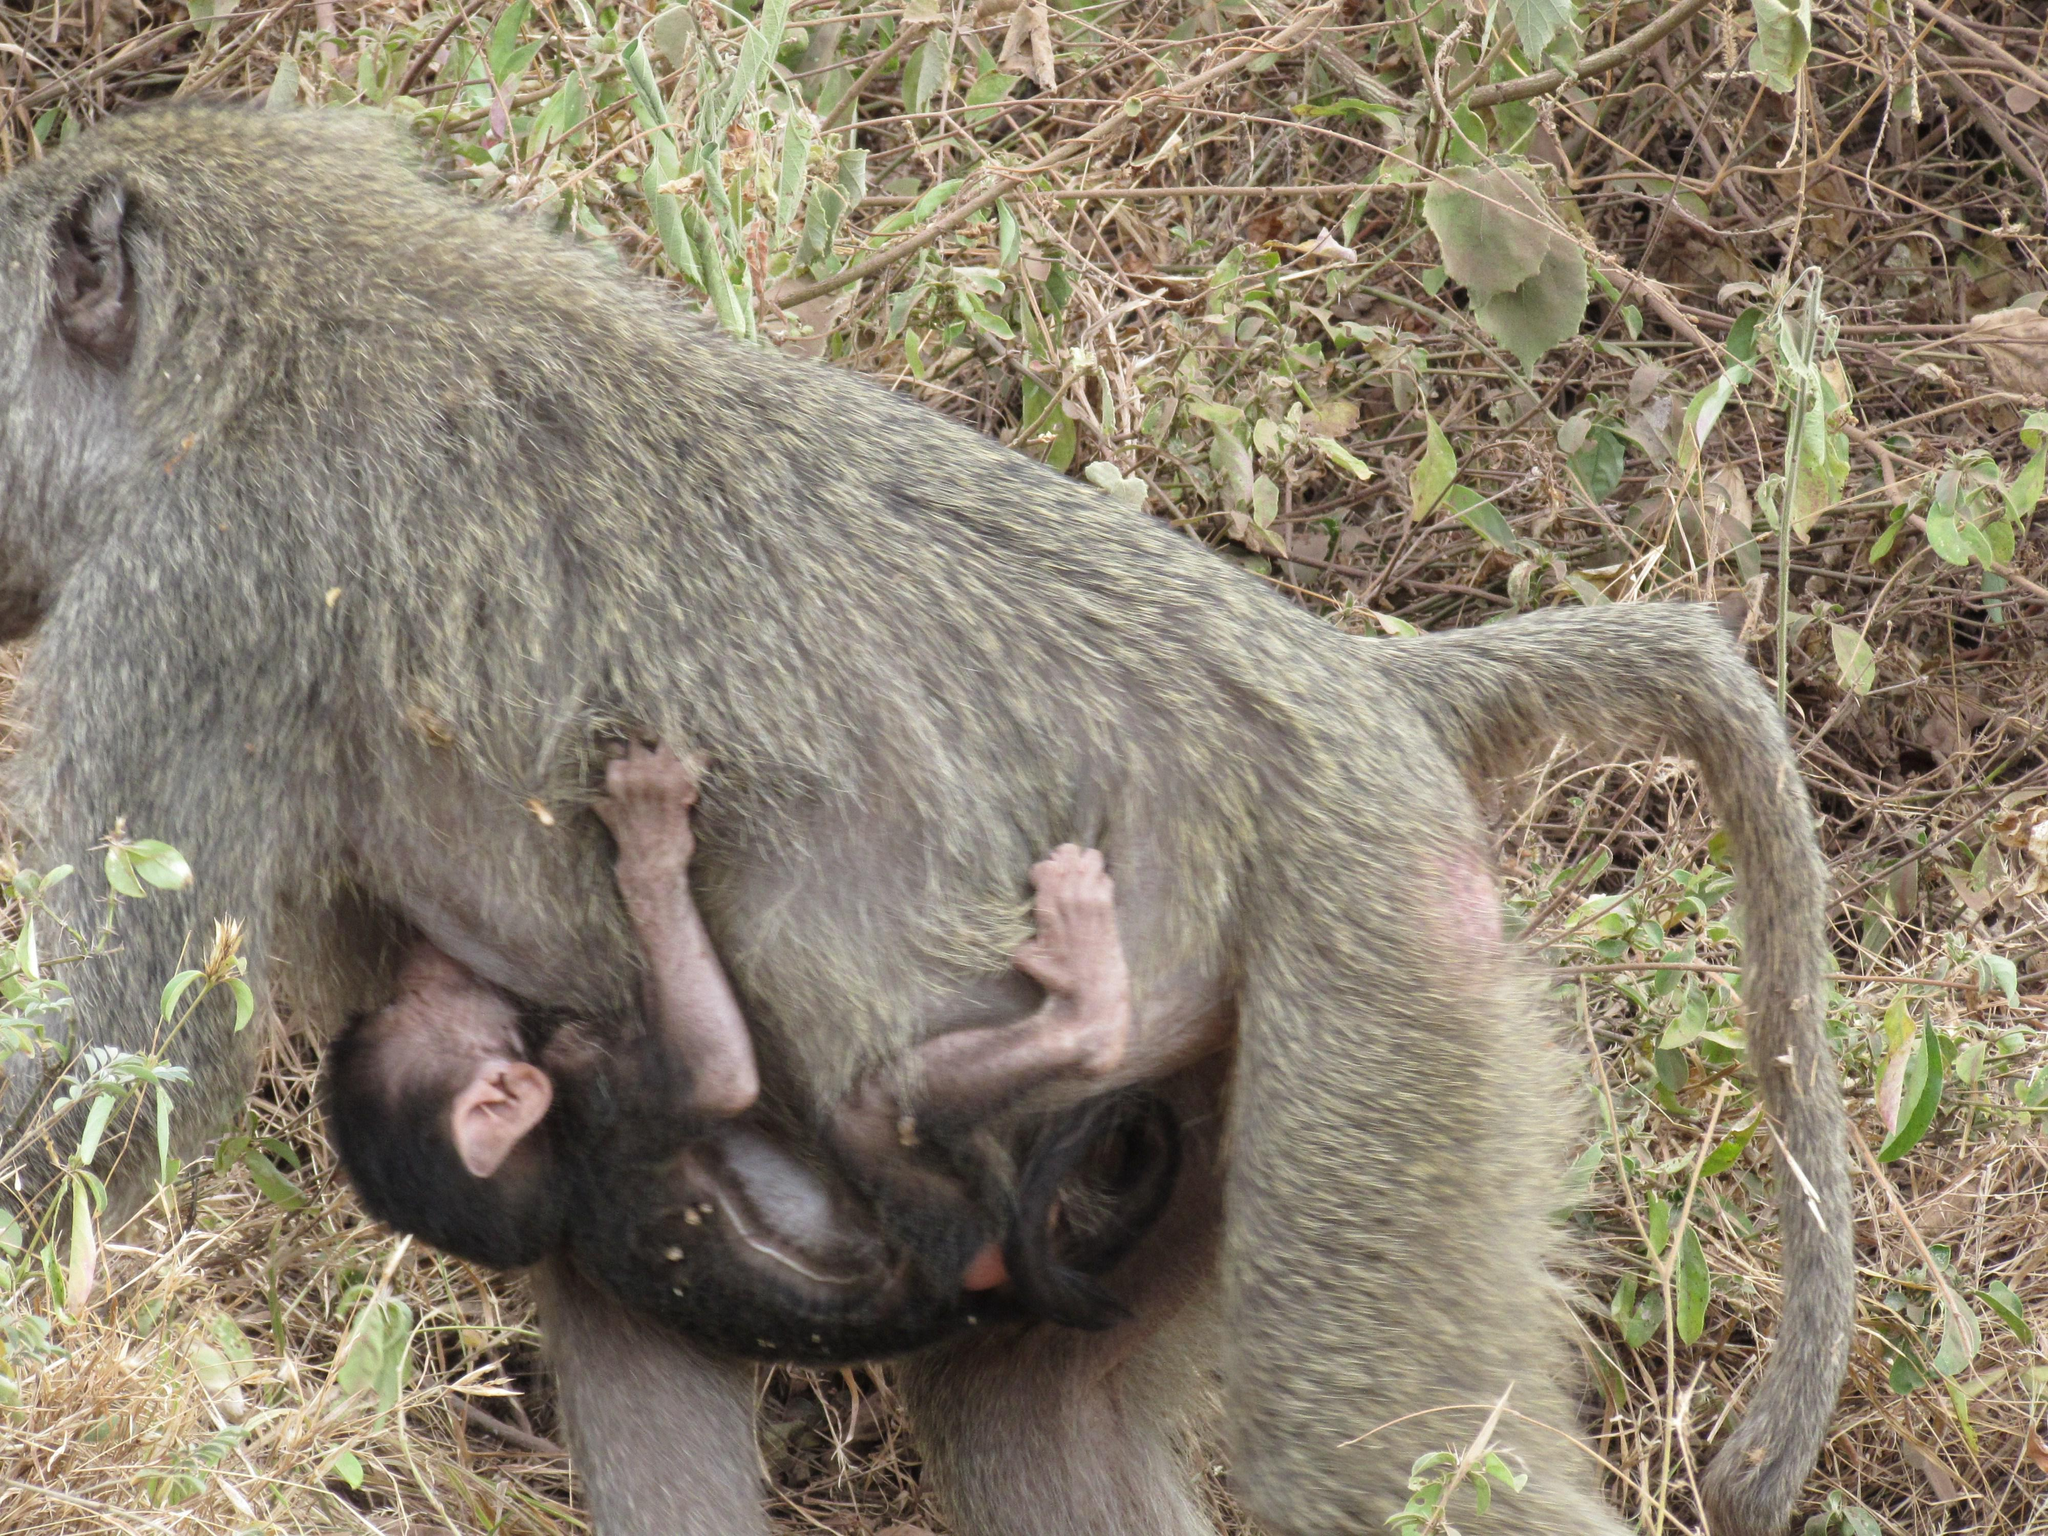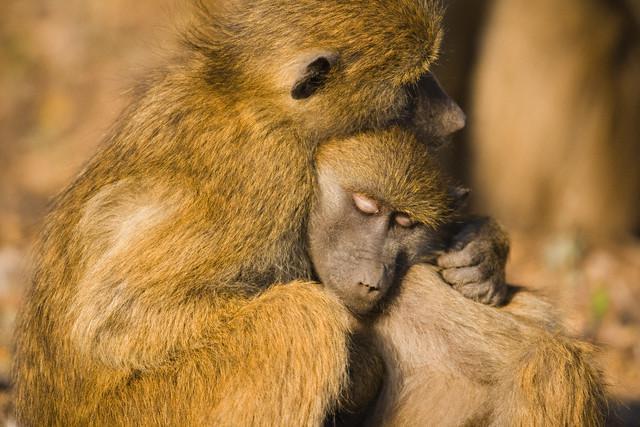The first image is the image on the left, the second image is the image on the right. Examine the images to the left and right. Is the description "One ape's teeth are visible." accurate? Answer yes or no. No. The first image is the image on the left, the second image is the image on the right. Examine the images to the left and right. Is the description "Each image contains multiple baboons but less than five baboons, and one image includes a baby baboon clinging to the chest of an adult baboon." accurate? Answer yes or no. Yes. 